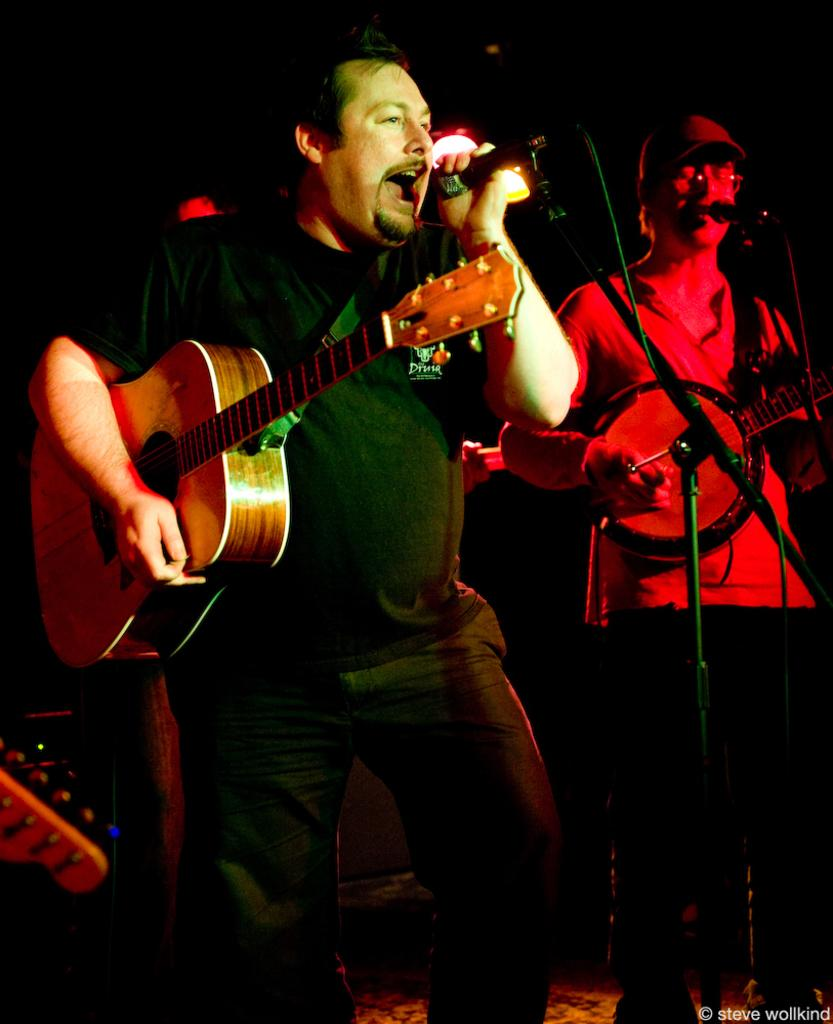How many people are in the image? There are two men in the image. What are the men doing in the image? The men are playing guitars and singing on microphones. What can be seen in the background of the image? The background of the image is dark. What is illuminating the scene in the image? There are lights visible in the image. What type of attraction can be seen in the background of the image? There is no attraction visible in the background of the image; it is dark with lights. How many bites have the men taken out of their guitars in the image? The men are not taking bites out of their guitars; they are playing them. 